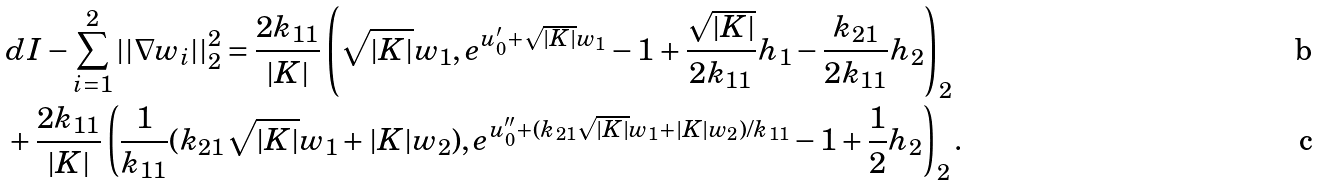Convert formula to latex. <formula><loc_0><loc_0><loc_500><loc_500>& d I - \sum _ { i = 1 } ^ { 2 } | | \nabla w _ { i } | | ^ { 2 } _ { 2 } = \frac { 2 k _ { 1 1 } } { | K | } \left ( \sqrt { | K | } w _ { 1 } , e ^ { u _ { 0 } ^ { \prime } + \sqrt { | K | } w _ { 1 } } - 1 + \frac { \sqrt { | K | } } { 2 k _ { 1 1 } } h _ { 1 } - \frac { k _ { 2 1 } } { 2 k _ { 1 1 } } h _ { 2 } \right ) _ { 2 } \\ & + \frac { 2 k _ { 1 1 } } { | K | } \left ( \frac { 1 } { k _ { 1 1 } } ( k _ { 2 1 } \sqrt { | K | } w _ { 1 } + | K | w _ { 2 } ) , e ^ { u _ { 0 } ^ { \prime \prime } + ( k _ { 2 1 } \sqrt { | K | } w _ { 1 } + | K | w _ { 2 } ) / k _ { 1 1 } } - 1 + \frac { 1 } { 2 } h _ { 2 } \right ) _ { 2 } .</formula> 